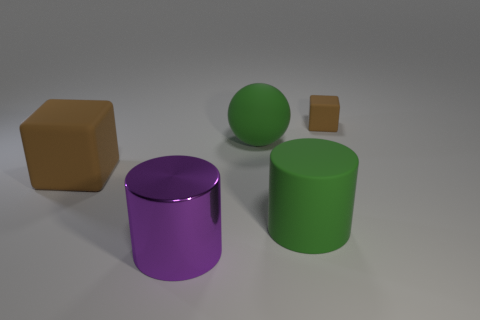Is there any other thing that is made of the same material as the big purple object?
Your answer should be compact. No. What is the shape of the large purple metallic thing?
Offer a very short reply. Cylinder. Does the large brown thing have the same shape as the big green object in front of the green sphere?
Your answer should be very brief. No. Is the shape of the large metal object that is in front of the large ball the same as  the tiny brown matte object?
Provide a short and direct response. No. How many other objects are there of the same shape as the purple shiny object?
Ensure brevity in your answer.  1. What material is the brown block that is on the left side of the large metal thing?
Ensure brevity in your answer.  Rubber. Is the number of balls that are to the right of the small brown rubber thing greater than the number of large matte balls?
Your answer should be very brief. No. There is a brown object that is on the left side of the rubber cube on the right side of the purple shiny thing; is there a big brown rubber cube that is behind it?
Offer a very short reply. No. There is a metal cylinder; are there any purple cylinders behind it?
Give a very brief answer. No. How many cylinders have the same color as the small matte thing?
Keep it short and to the point. 0. 